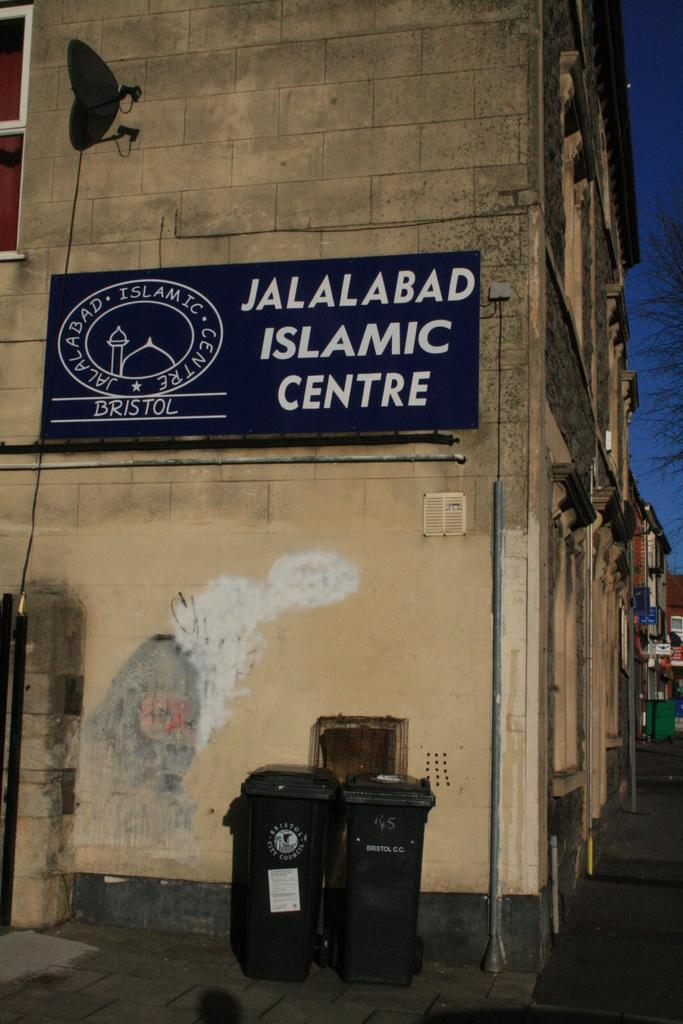<image>
Share a concise interpretation of the image provided. Outside of an old building reading Jalalabad Islamic Centre 